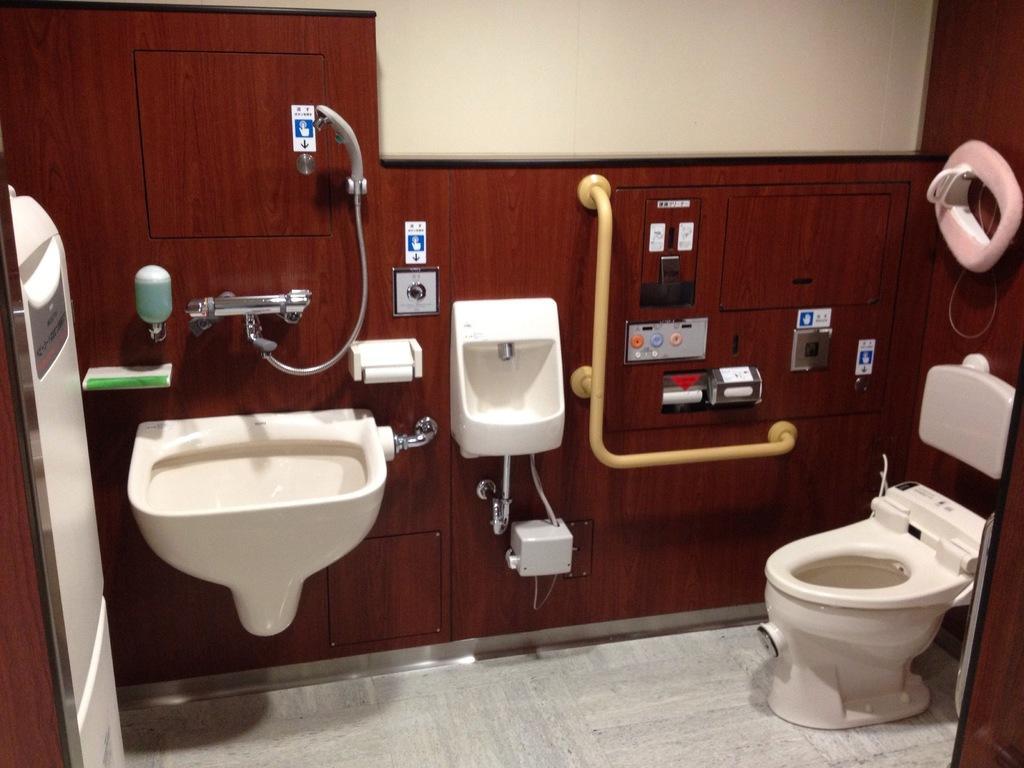Describe this image in one or two sentences. In this picture there is a inside of the bathroom. In the front there is a white color commode with tissue papers and sensor. Beside there is a yellow color hand dryer and a wash basin with soap holder. On the top there is a glass window with white color sheet. 